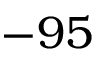Convert formula to latex. <formula><loc_0><loc_0><loc_500><loc_500>- 9 5</formula> 